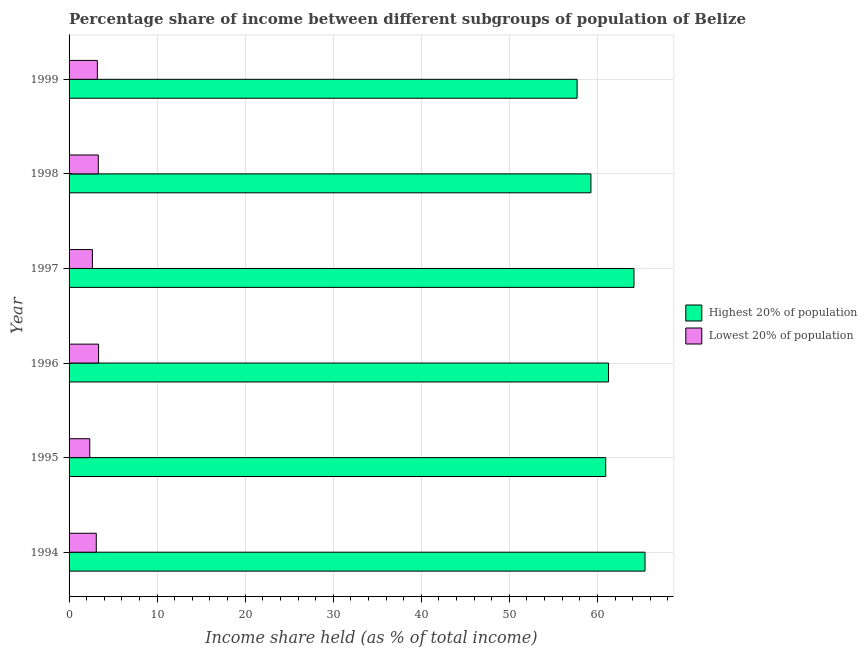How many different coloured bars are there?
Your answer should be very brief. 2. What is the income share held by highest 20% of the population in 1998?
Ensure brevity in your answer.  59.26. Across all years, what is the maximum income share held by highest 20% of the population?
Keep it short and to the point. 65.4. Across all years, what is the minimum income share held by lowest 20% of the population?
Make the answer very short. 2.35. In which year was the income share held by lowest 20% of the population minimum?
Your answer should be very brief. 1995. What is the total income share held by lowest 20% of the population in the graph?
Offer a terse response. 17.97. What is the difference between the income share held by highest 20% of the population in 1994 and that in 1999?
Keep it short and to the point. 7.71. What is the difference between the income share held by lowest 20% of the population in 1995 and the income share held by highest 20% of the population in 1994?
Keep it short and to the point. -63.05. What is the average income share held by lowest 20% of the population per year?
Offer a very short reply. 3. In the year 1999, what is the difference between the income share held by lowest 20% of the population and income share held by highest 20% of the population?
Provide a short and direct response. -54.48. What is the ratio of the income share held by highest 20% of the population in 1996 to that in 1997?
Ensure brevity in your answer.  0.95. Is the income share held by lowest 20% of the population in 1994 less than that in 1999?
Make the answer very short. Yes. Is the difference between the income share held by highest 20% of the population in 1997 and 1998 greater than the difference between the income share held by lowest 20% of the population in 1997 and 1998?
Your response must be concise. Yes. What is the difference between the highest and the second highest income share held by lowest 20% of the population?
Your response must be concise. 0.03. What is the difference between the highest and the lowest income share held by highest 20% of the population?
Make the answer very short. 7.71. In how many years, is the income share held by highest 20% of the population greater than the average income share held by highest 20% of the population taken over all years?
Ensure brevity in your answer.  2. What does the 1st bar from the top in 1999 represents?
Make the answer very short. Lowest 20% of population. What does the 2nd bar from the bottom in 1996 represents?
Offer a terse response. Lowest 20% of population. How many bars are there?
Keep it short and to the point. 12. How many years are there in the graph?
Offer a very short reply. 6. Does the graph contain any zero values?
Make the answer very short. No. Where does the legend appear in the graph?
Offer a very short reply. Center right. What is the title of the graph?
Keep it short and to the point. Percentage share of income between different subgroups of population of Belize. What is the label or title of the X-axis?
Give a very brief answer. Income share held (as % of total income). What is the Income share held (as % of total income) of Highest 20% of population in 1994?
Your response must be concise. 65.4. What is the Income share held (as % of total income) of Lowest 20% of population in 1994?
Ensure brevity in your answer.  3.09. What is the Income share held (as % of total income) in Highest 20% of population in 1995?
Provide a succinct answer. 60.94. What is the Income share held (as % of total income) in Lowest 20% of population in 1995?
Provide a succinct answer. 2.35. What is the Income share held (as % of total income) of Highest 20% of population in 1996?
Offer a terse response. 61.26. What is the Income share held (as % of total income) of Lowest 20% of population in 1996?
Your response must be concise. 3.35. What is the Income share held (as % of total income) in Highest 20% of population in 1997?
Keep it short and to the point. 64.15. What is the Income share held (as % of total income) of Lowest 20% of population in 1997?
Your response must be concise. 2.65. What is the Income share held (as % of total income) in Highest 20% of population in 1998?
Your response must be concise. 59.26. What is the Income share held (as % of total income) in Lowest 20% of population in 1998?
Provide a succinct answer. 3.32. What is the Income share held (as % of total income) of Highest 20% of population in 1999?
Make the answer very short. 57.69. What is the Income share held (as % of total income) in Lowest 20% of population in 1999?
Make the answer very short. 3.21. Across all years, what is the maximum Income share held (as % of total income) of Highest 20% of population?
Provide a short and direct response. 65.4. Across all years, what is the maximum Income share held (as % of total income) in Lowest 20% of population?
Provide a short and direct response. 3.35. Across all years, what is the minimum Income share held (as % of total income) in Highest 20% of population?
Provide a succinct answer. 57.69. Across all years, what is the minimum Income share held (as % of total income) in Lowest 20% of population?
Provide a short and direct response. 2.35. What is the total Income share held (as % of total income) of Highest 20% of population in the graph?
Keep it short and to the point. 368.7. What is the total Income share held (as % of total income) in Lowest 20% of population in the graph?
Make the answer very short. 17.97. What is the difference between the Income share held (as % of total income) of Highest 20% of population in 1994 and that in 1995?
Give a very brief answer. 4.46. What is the difference between the Income share held (as % of total income) in Lowest 20% of population in 1994 and that in 1995?
Ensure brevity in your answer.  0.74. What is the difference between the Income share held (as % of total income) in Highest 20% of population in 1994 and that in 1996?
Your answer should be very brief. 4.14. What is the difference between the Income share held (as % of total income) in Lowest 20% of population in 1994 and that in 1996?
Offer a terse response. -0.26. What is the difference between the Income share held (as % of total income) in Highest 20% of population in 1994 and that in 1997?
Your answer should be very brief. 1.25. What is the difference between the Income share held (as % of total income) of Lowest 20% of population in 1994 and that in 1997?
Keep it short and to the point. 0.44. What is the difference between the Income share held (as % of total income) of Highest 20% of population in 1994 and that in 1998?
Your answer should be compact. 6.14. What is the difference between the Income share held (as % of total income) in Lowest 20% of population in 1994 and that in 1998?
Your answer should be very brief. -0.23. What is the difference between the Income share held (as % of total income) of Highest 20% of population in 1994 and that in 1999?
Give a very brief answer. 7.71. What is the difference between the Income share held (as % of total income) of Lowest 20% of population in 1994 and that in 1999?
Your answer should be compact. -0.12. What is the difference between the Income share held (as % of total income) in Highest 20% of population in 1995 and that in 1996?
Your answer should be compact. -0.32. What is the difference between the Income share held (as % of total income) in Lowest 20% of population in 1995 and that in 1996?
Give a very brief answer. -1. What is the difference between the Income share held (as % of total income) of Highest 20% of population in 1995 and that in 1997?
Your answer should be compact. -3.21. What is the difference between the Income share held (as % of total income) of Lowest 20% of population in 1995 and that in 1997?
Ensure brevity in your answer.  -0.3. What is the difference between the Income share held (as % of total income) in Highest 20% of population in 1995 and that in 1998?
Offer a terse response. 1.68. What is the difference between the Income share held (as % of total income) of Lowest 20% of population in 1995 and that in 1998?
Offer a very short reply. -0.97. What is the difference between the Income share held (as % of total income) in Highest 20% of population in 1995 and that in 1999?
Ensure brevity in your answer.  3.25. What is the difference between the Income share held (as % of total income) of Lowest 20% of population in 1995 and that in 1999?
Keep it short and to the point. -0.86. What is the difference between the Income share held (as % of total income) in Highest 20% of population in 1996 and that in 1997?
Keep it short and to the point. -2.89. What is the difference between the Income share held (as % of total income) in Lowest 20% of population in 1996 and that in 1997?
Make the answer very short. 0.7. What is the difference between the Income share held (as % of total income) of Highest 20% of population in 1996 and that in 1998?
Your answer should be compact. 2. What is the difference between the Income share held (as % of total income) of Lowest 20% of population in 1996 and that in 1998?
Your answer should be very brief. 0.03. What is the difference between the Income share held (as % of total income) in Highest 20% of population in 1996 and that in 1999?
Offer a terse response. 3.57. What is the difference between the Income share held (as % of total income) of Lowest 20% of population in 1996 and that in 1999?
Provide a short and direct response. 0.14. What is the difference between the Income share held (as % of total income) of Highest 20% of population in 1997 and that in 1998?
Make the answer very short. 4.89. What is the difference between the Income share held (as % of total income) in Lowest 20% of population in 1997 and that in 1998?
Your answer should be compact. -0.67. What is the difference between the Income share held (as % of total income) in Highest 20% of population in 1997 and that in 1999?
Make the answer very short. 6.46. What is the difference between the Income share held (as % of total income) in Lowest 20% of population in 1997 and that in 1999?
Provide a short and direct response. -0.56. What is the difference between the Income share held (as % of total income) in Highest 20% of population in 1998 and that in 1999?
Your answer should be very brief. 1.57. What is the difference between the Income share held (as % of total income) in Lowest 20% of population in 1998 and that in 1999?
Provide a succinct answer. 0.11. What is the difference between the Income share held (as % of total income) in Highest 20% of population in 1994 and the Income share held (as % of total income) in Lowest 20% of population in 1995?
Offer a terse response. 63.05. What is the difference between the Income share held (as % of total income) of Highest 20% of population in 1994 and the Income share held (as % of total income) of Lowest 20% of population in 1996?
Your answer should be compact. 62.05. What is the difference between the Income share held (as % of total income) of Highest 20% of population in 1994 and the Income share held (as % of total income) of Lowest 20% of population in 1997?
Your answer should be compact. 62.75. What is the difference between the Income share held (as % of total income) in Highest 20% of population in 1994 and the Income share held (as % of total income) in Lowest 20% of population in 1998?
Ensure brevity in your answer.  62.08. What is the difference between the Income share held (as % of total income) in Highest 20% of population in 1994 and the Income share held (as % of total income) in Lowest 20% of population in 1999?
Offer a very short reply. 62.19. What is the difference between the Income share held (as % of total income) in Highest 20% of population in 1995 and the Income share held (as % of total income) in Lowest 20% of population in 1996?
Make the answer very short. 57.59. What is the difference between the Income share held (as % of total income) in Highest 20% of population in 1995 and the Income share held (as % of total income) in Lowest 20% of population in 1997?
Your response must be concise. 58.29. What is the difference between the Income share held (as % of total income) in Highest 20% of population in 1995 and the Income share held (as % of total income) in Lowest 20% of population in 1998?
Keep it short and to the point. 57.62. What is the difference between the Income share held (as % of total income) in Highest 20% of population in 1995 and the Income share held (as % of total income) in Lowest 20% of population in 1999?
Offer a very short reply. 57.73. What is the difference between the Income share held (as % of total income) in Highest 20% of population in 1996 and the Income share held (as % of total income) in Lowest 20% of population in 1997?
Give a very brief answer. 58.61. What is the difference between the Income share held (as % of total income) of Highest 20% of population in 1996 and the Income share held (as % of total income) of Lowest 20% of population in 1998?
Your answer should be compact. 57.94. What is the difference between the Income share held (as % of total income) in Highest 20% of population in 1996 and the Income share held (as % of total income) in Lowest 20% of population in 1999?
Keep it short and to the point. 58.05. What is the difference between the Income share held (as % of total income) of Highest 20% of population in 1997 and the Income share held (as % of total income) of Lowest 20% of population in 1998?
Offer a very short reply. 60.83. What is the difference between the Income share held (as % of total income) in Highest 20% of population in 1997 and the Income share held (as % of total income) in Lowest 20% of population in 1999?
Give a very brief answer. 60.94. What is the difference between the Income share held (as % of total income) of Highest 20% of population in 1998 and the Income share held (as % of total income) of Lowest 20% of population in 1999?
Make the answer very short. 56.05. What is the average Income share held (as % of total income) in Highest 20% of population per year?
Ensure brevity in your answer.  61.45. What is the average Income share held (as % of total income) of Lowest 20% of population per year?
Offer a very short reply. 3. In the year 1994, what is the difference between the Income share held (as % of total income) in Highest 20% of population and Income share held (as % of total income) in Lowest 20% of population?
Offer a very short reply. 62.31. In the year 1995, what is the difference between the Income share held (as % of total income) in Highest 20% of population and Income share held (as % of total income) in Lowest 20% of population?
Give a very brief answer. 58.59. In the year 1996, what is the difference between the Income share held (as % of total income) of Highest 20% of population and Income share held (as % of total income) of Lowest 20% of population?
Ensure brevity in your answer.  57.91. In the year 1997, what is the difference between the Income share held (as % of total income) of Highest 20% of population and Income share held (as % of total income) of Lowest 20% of population?
Give a very brief answer. 61.5. In the year 1998, what is the difference between the Income share held (as % of total income) of Highest 20% of population and Income share held (as % of total income) of Lowest 20% of population?
Your response must be concise. 55.94. In the year 1999, what is the difference between the Income share held (as % of total income) in Highest 20% of population and Income share held (as % of total income) in Lowest 20% of population?
Your response must be concise. 54.48. What is the ratio of the Income share held (as % of total income) in Highest 20% of population in 1994 to that in 1995?
Offer a terse response. 1.07. What is the ratio of the Income share held (as % of total income) in Lowest 20% of population in 1994 to that in 1995?
Ensure brevity in your answer.  1.31. What is the ratio of the Income share held (as % of total income) of Highest 20% of population in 1994 to that in 1996?
Keep it short and to the point. 1.07. What is the ratio of the Income share held (as % of total income) in Lowest 20% of population in 1994 to that in 1996?
Ensure brevity in your answer.  0.92. What is the ratio of the Income share held (as % of total income) of Highest 20% of population in 1994 to that in 1997?
Your answer should be compact. 1.02. What is the ratio of the Income share held (as % of total income) of Lowest 20% of population in 1994 to that in 1997?
Provide a succinct answer. 1.17. What is the ratio of the Income share held (as % of total income) in Highest 20% of population in 1994 to that in 1998?
Your response must be concise. 1.1. What is the ratio of the Income share held (as % of total income) in Lowest 20% of population in 1994 to that in 1998?
Provide a succinct answer. 0.93. What is the ratio of the Income share held (as % of total income) in Highest 20% of population in 1994 to that in 1999?
Make the answer very short. 1.13. What is the ratio of the Income share held (as % of total income) in Lowest 20% of population in 1994 to that in 1999?
Provide a succinct answer. 0.96. What is the ratio of the Income share held (as % of total income) in Lowest 20% of population in 1995 to that in 1996?
Your response must be concise. 0.7. What is the ratio of the Income share held (as % of total income) in Lowest 20% of population in 1995 to that in 1997?
Keep it short and to the point. 0.89. What is the ratio of the Income share held (as % of total income) of Highest 20% of population in 1995 to that in 1998?
Give a very brief answer. 1.03. What is the ratio of the Income share held (as % of total income) in Lowest 20% of population in 1995 to that in 1998?
Make the answer very short. 0.71. What is the ratio of the Income share held (as % of total income) in Highest 20% of population in 1995 to that in 1999?
Ensure brevity in your answer.  1.06. What is the ratio of the Income share held (as % of total income) in Lowest 20% of population in 1995 to that in 1999?
Offer a very short reply. 0.73. What is the ratio of the Income share held (as % of total income) of Highest 20% of population in 1996 to that in 1997?
Ensure brevity in your answer.  0.95. What is the ratio of the Income share held (as % of total income) of Lowest 20% of population in 1996 to that in 1997?
Keep it short and to the point. 1.26. What is the ratio of the Income share held (as % of total income) in Highest 20% of population in 1996 to that in 1998?
Keep it short and to the point. 1.03. What is the ratio of the Income share held (as % of total income) in Highest 20% of population in 1996 to that in 1999?
Give a very brief answer. 1.06. What is the ratio of the Income share held (as % of total income) in Lowest 20% of population in 1996 to that in 1999?
Give a very brief answer. 1.04. What is the ratio of the Income share held (as % of total income) in Highest 20% of population in 1997 to that in 1998?
Offer a very short reply. 1.08. What is the ratio of the Income share held (as % of total income) of Lowest 20% of population in 1997 to that in 1998?
Give a very brief answer. 0.8. What is the ratio of the Income share held (as % of total income) in Highest 20% of population in 1997 to that in 1999?
Your answer should be very brief. 1.11. What is the ratio of the Income share held (as % of total income) in Lowest 20% of population in 1997 to that in 1999?
Ensure brevity in your answer.  0.83. What is the ratio of the Income share held (as % of total income) in Highest 20% of population in 1998 to that in 1999?
Keep it short and to the point. 1.03. What is the ratio of the Income share held (as % of total income) in Lowest 20% of population in 1998 to that in 1999?
Provide a short and direct response. 1.03. What is the difference between the highest and the second highest Income share held (as % of total income) of Highest 20% of population?
Give a very brief answer. 1.25. What is the difference between the highest and the second highest Income share held (as % of total income) of Lowest 20% of population?
Give a very brief answer. 0.03. What is the difference between the highest and the lowest Income share held (as % of total income) in Highest 20% of population?
Provide a succinct answer. 7.71. What is the difference between the highest and the lowest Income share held (as % of total income) in Lowest 20% of population?
Offer a very short reply. 1. 